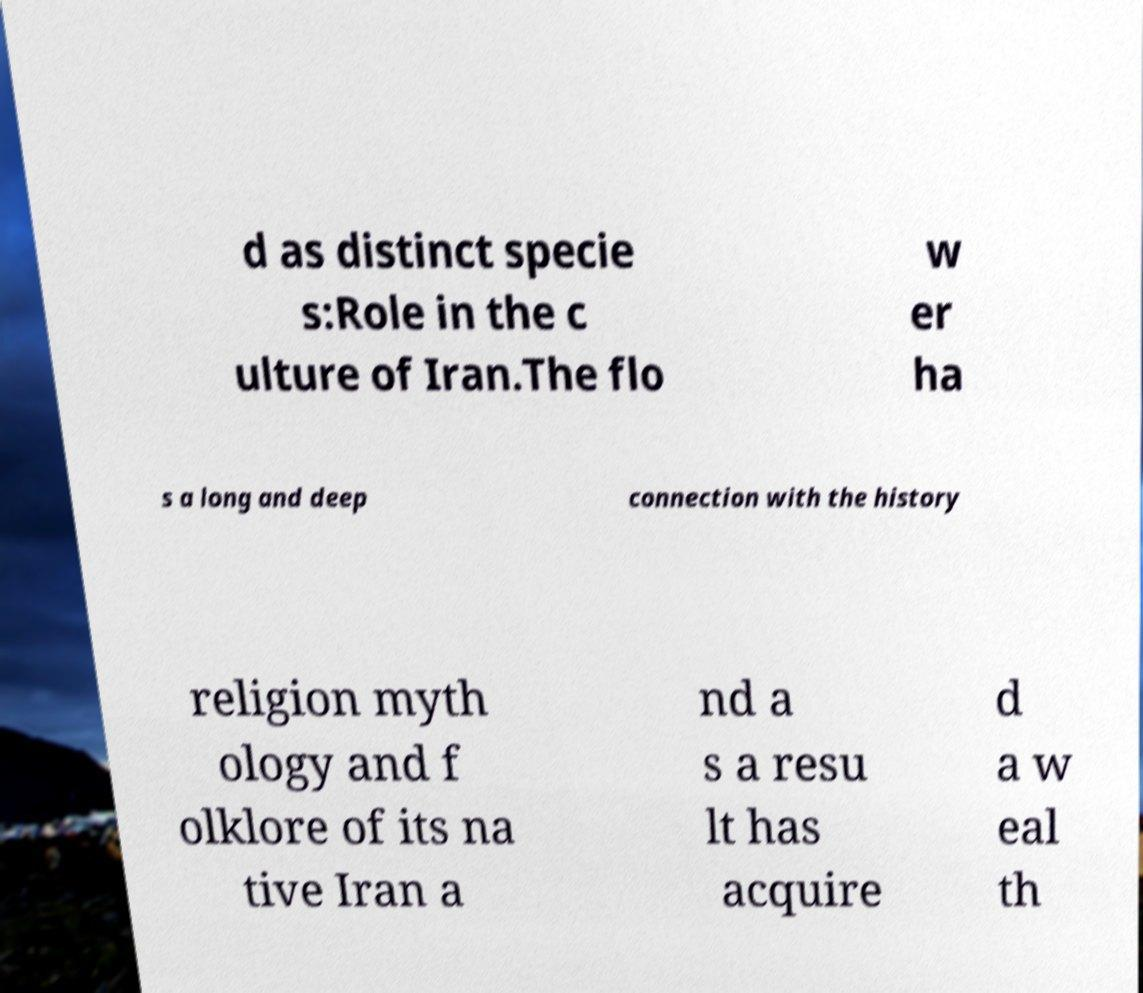Can you accurately transcribe the text from the provided image for me? d as distinct specie s:Role in the c ulture of Iran.The flo w er ha s a long and deep connection with the history religion myth ology and f olklore of its na tive Iran a nd a s a resu lt has acquire d a w eal th 